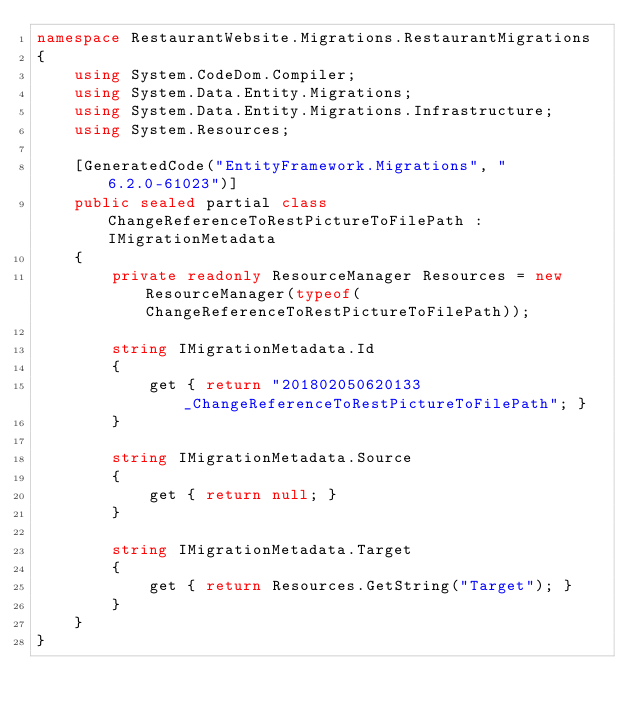Convert code to text. <code><loc_0><loc_0><loc_500><loc_500><_C#_>namespace RestaurantWebsite.Migrations.RestaurantMigrations
{
    using System.CodeDom.Compiler;
    using System.Data.Entity.Migrations;
    using System.Data.Entity.Migrations.Infrastructure;
    using System.Resources;
    
    [GeneratedCode("EntityFramework.Migrations", "6.2.0-61023")]
    public sealed partial class ChangeReferenceToRestPictureToFilePath : IMigrationMetadata
    {
        private readonly ResourceManager Resources = new ResourceManager(typeof(ChangeReferenceToRestPictureToFilePath));
        
        string IMigrationMetadata.Id
        {
            get { return "201802050620133_ChangeReferenceToRestPictureToFilePath"; }
        }
        
        string IMigrationMetadata.Source
        {
            get { return null; }
        }
        
        string IMigrationMetadata.Target
        {
            get { return Resources.GetString("Target"); }
        }
    }
}
</code> 